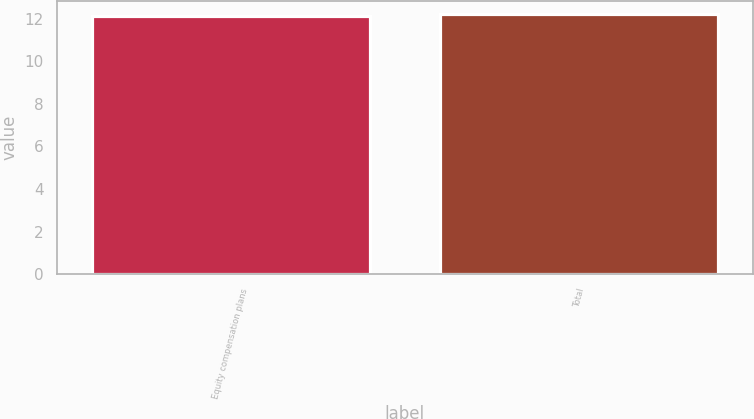Convert chart. <chart><loc_0><loc_0><loc_500><loc_500><bar_chart><fcel>Equity compensation plans<fcel>Total<nl><fcel>12.12<fcel>12.22<nl></chart> 